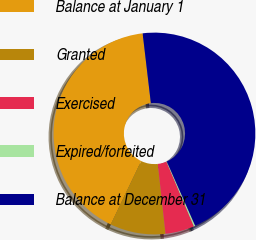<chart> <loc_0><loc_0><loc_500><loc_500><pie_chart><fcel>Balance at January 1<fcel>Granted<fcel>Exercised<fcel>Expired/forfeited<fcel>Balance at December 31<nl><fcel>41.01%<fcel>8.87%<fcel>4.64%<fcel>0.23%<fcel>45.25%<nl></chart> 